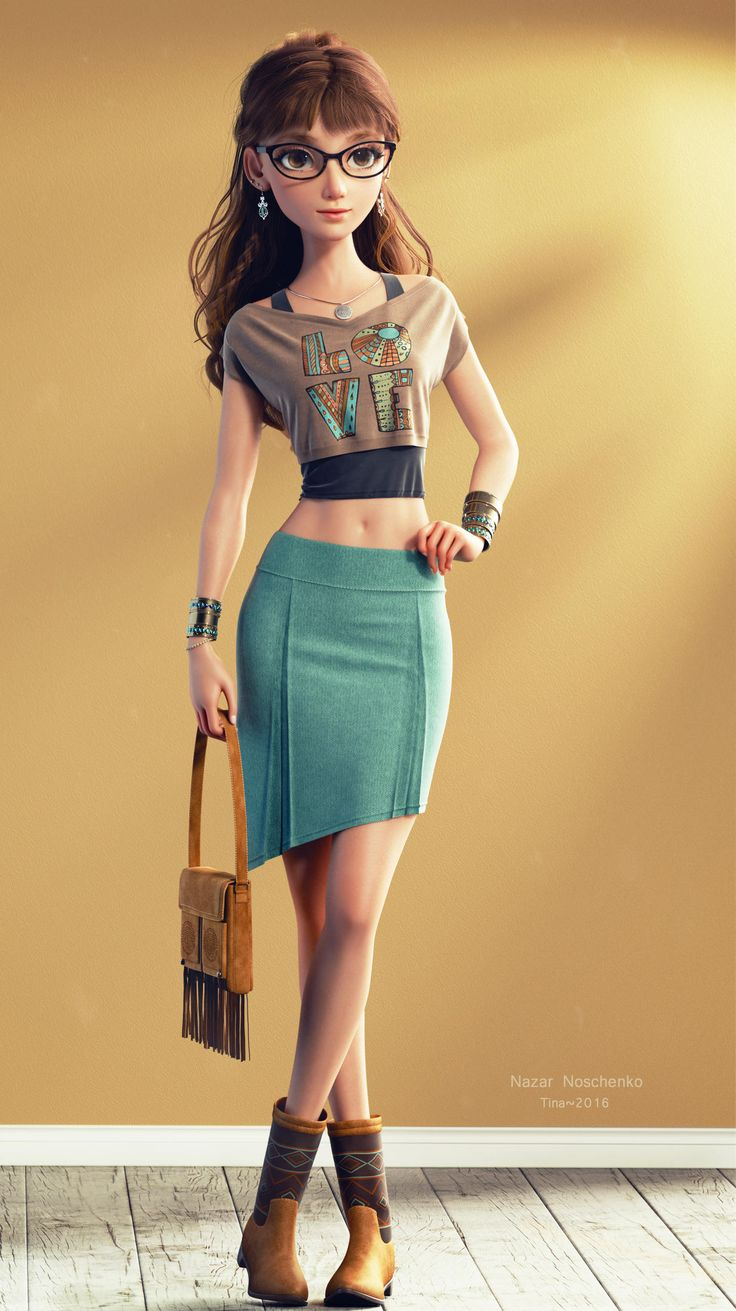walking cycle girl This is an image of a 3D-rendered character who appears to be a young woman with a modern, casual style. She has brown hair tied back in a ponytail, wears glasses, and is accessorized with earrings, bracelets, and a necklace. The character is wearing a cropped T-shirt with the word "LOVE" printed on it, a teal pencil skirt, and brown ankle boots. She is also carrying a tan shoulder bag with fringe detailing. The image is stylized and the character is posed in a manner that suggests she could be walking or standing with a slight shift in weight, but since it's a still image, there's no actual motion. The watermark indicates that the artwork was created by Nazar Noschenko in 2016, and the character's name appears to be Tina, according to the text in the image. 